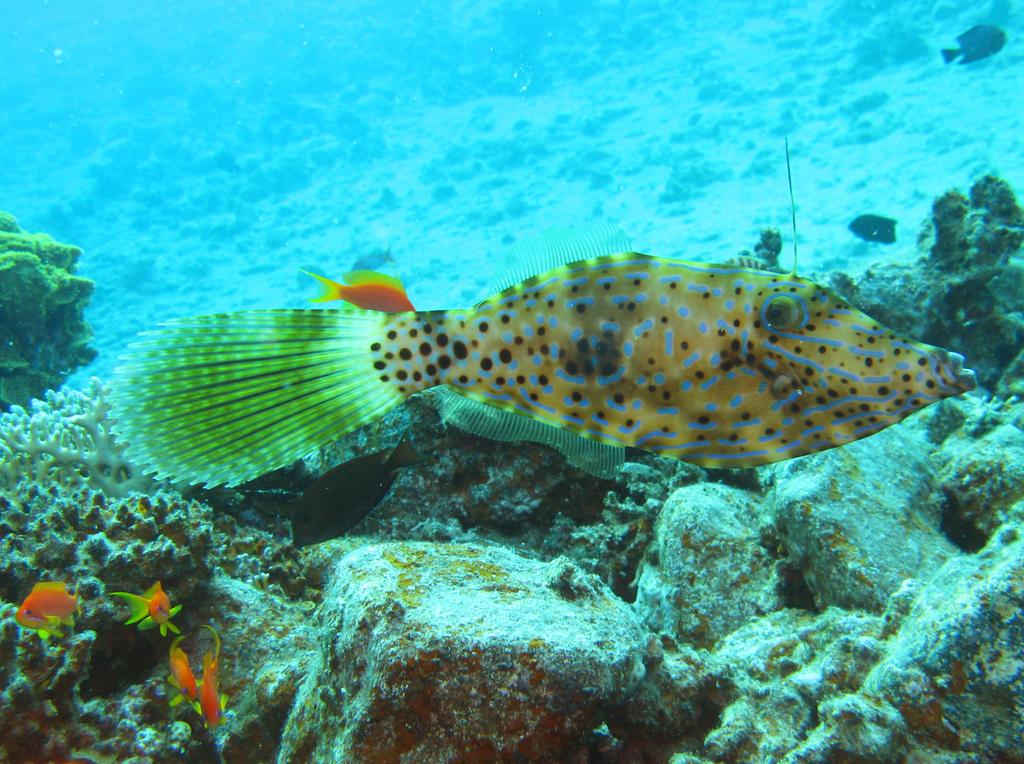What type of animals can be seen in the image? There are aquatic animals in the image. Where are the aquatic animals located? The aquatic animals are in the water. What can be found at the bottom of the image? There are rocks at the bottom of the image. What type of government is depicted in the image? There is no government depicted in the image; it features aquatic animals in the water with rocks at the bottom. 